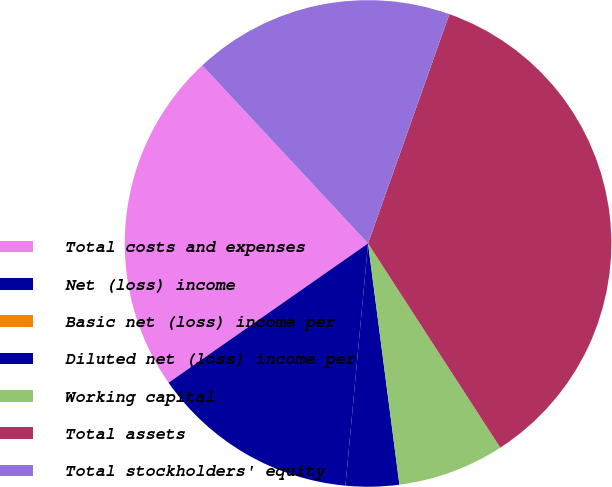Convert chart. <chart><loc_0><loc_0><loc_500><loc_500><pie_chart><fcel>Total costs and expenses<fcel>Net (loss) income<fcel>Basic net (loss) income per<fcel>Diluted net (loss) income per<fcel>Working capital<fcel>Total assets<fcel>Total stockholders' equity<nl><fcel>22.77%<fcel>13.82%<fcel>0.0%<fcel>3.54%<fcel>7.09%<fcel>35.43%<fcel>17.36%<nl></chart> 